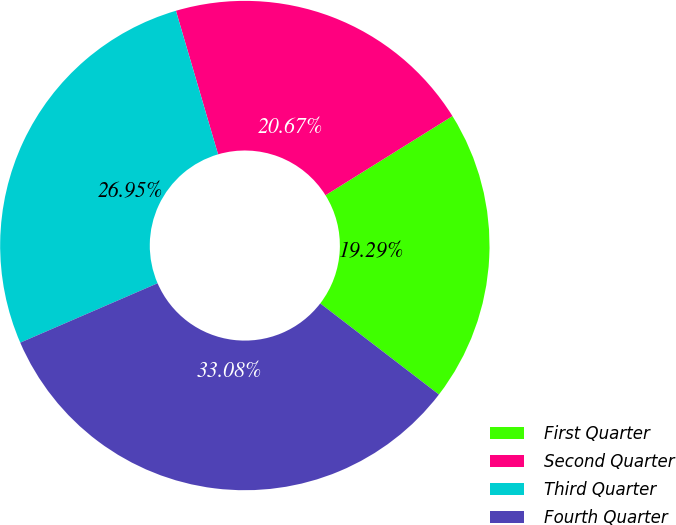Convert chart to OTSL. <chart><loc_0><loc_0><loc_500><loc_500><pie_chart><fcel>First Quarter<fcel>Second Quarter<fcel>Third Quarter<fcel>Fourth Quarter<nl><fcel>19.29%<fcel>20.67%<fcel>26.95%<fcel>33.08%<nl></chart> 